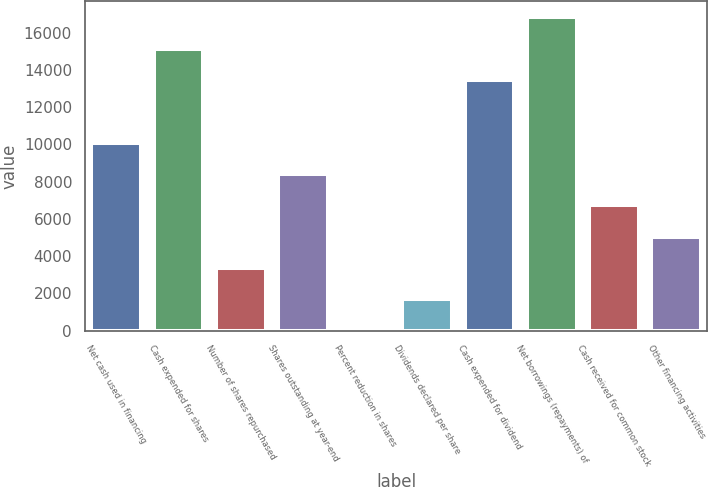Convert chart to OTSL. <chart><loc_0><loc_0><loc_500><loc_500><bar_chart><fcel>Net cash used in financing<fcel>Cash expended for shares<fcel>Number of shares repurchased<fcel>Shares outstanding at year-end<fcel>Percent reduction in shares<fcel>Dividends declared per share<fcel>Cash expended for dividend<fcel>Net borrowings (repayments) of<fcel>Cash received for common stock<fcel>Other financing activities<nl><fcel>10095.8<fcel>15142.7<fcel>3366.68<fcel>8413.55<fcel>2.1<fcel>1684.39<fcel>13460.4<fcel>16825<fcel>6731.26<fcel>5048.97<nl></chart> 